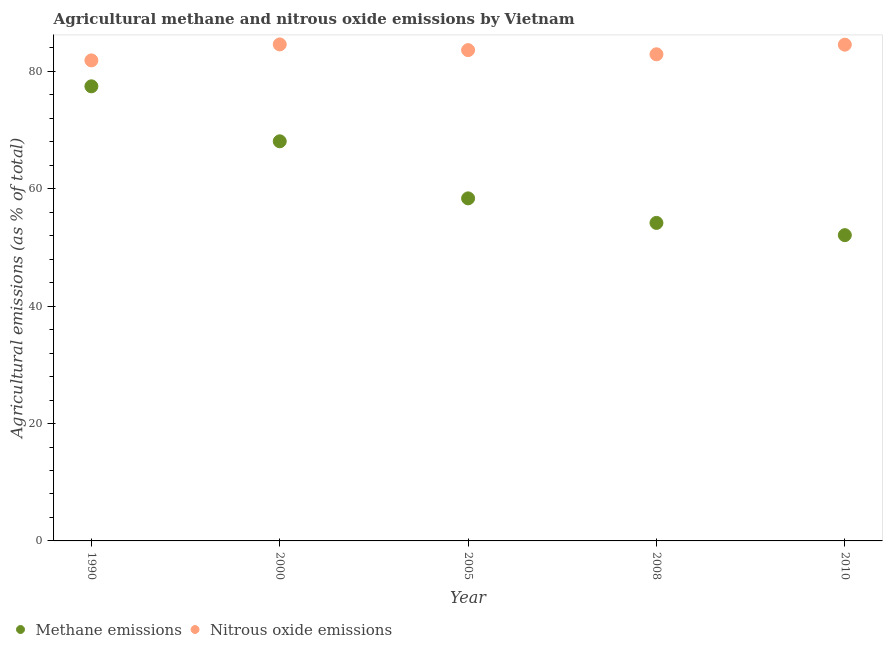How many different coloured dotlines are there?
Give a very brief answer. 2. What is the amount of methane emissions in 2000?
Your response must be concise. 68.1. Across all years, what is the maximum amount of methane emissions?
Offer a very short reply. 77.47. Across all years, what is the minimum amount of methane emissions?
Your answer should be very brief. 52.11. In which year was the amount of nitrous oxide emissions minimum?
Offer a terse response. 1990. What is the total amount of methane emissions in the graph?
Your answer should be very brief. 310.24. What is the difference between the amount of methane emissions in 2000 and that in 2005?
Your answer should be very brief. 9.72. What is the difference between the amount of methane emissions in 2010 and the amount of nitrous oxide emissions in 2008?
Ensure brevity in your answer.  -30.82. What is the average amount of methane emissions per year?
Your answer should be very brief. 62.05. In the year 1990, what is the difference between the amount of nitrous oxide emissions and amount of methane emissions?
Keep it short and to the point. 4.42. What is the ratio of the amount of methane emissions in 1990 to that in 2010?
Make the answer very short. 1.49. Is the amount of nitrous oxide emissions in 1990 less than that in 2000?
Make the answer very short. Yes. Is the difference between the amount of nitrous oxide emissions in 2000 and 2008 greater than the difference between the amount of methane emissions in 2000 and 2008?
Offer a terse response. No. What is the difference between the highest and the second highest amount of nitrous oxide emissions?
Provide a succinct answer. 0.04. What is the difference between the highest and the lowest amount of nitrous oxide emissions?
Offer a very short reply. 2.72. Does the amount of nitrous oxide emissions monotonically increase over the years?
Your response must be concise. No. Is the amount of methane emissions strictly greater than the amount of nitrous oxide emissions over the years?
Your answer should be compact. No. Is the amount of nitrous oxide emissions strictly less than the amount of methane emissions over the years?
Offer a terse response. No. How many dotlines are there?
Ensure brevity in your answer.  2. Are the values on the major ticks of Y-axis written in scientific E-notation?
Provide a succinct answer. No. How many legend labels are there?
Your answer should be very brief. 2. What is the title of the graph?
Ensure brevity in your answer.  Agricultural methane and nitrous oxide emissions by Vietnam. Does "Forest" appear as one of the legend labels in the graph?
Provide a succinct answer. No. What is the label or title of the X-axis?
Your response must be concise. Year. What is the label or title of the Y-axis?
Keep it short and to the point. Agricultural emissions (as % of total). What is the Agricultural emissions (as % of total) in Methane emissions in 1990?
Your answer should be very brief. 77.47. What is the Agricultural emissions (as % of total) of Nitrous oxide emissions in 1990?
Provide a short and direct response. 81.89. What is the Agricultural emissions (as % of total) in Methane emissions in 2000?
Offer a very short reply. 68.1. What is the Agricultural emissions (as % of total) in Nitrous oxide emissions in 2000?
Your response must be concise. 84.61. What is the Agricultural emissions (as % of total) in Methane emissions in 2005?
Provide a short and direct response. 58.37. What is the Agricultural emissions (as % of total) in Nitrous oxide emissions in 2005?
Offer a terse response. 83.64. What is the Agricultural emissions (as % of total) of Methane emissions in 2008?
Provide a short and direct response. 54.19. What is the Agricultural emissions (as % of total) in Nitrous oxide emissions in 2008?
Offer a terse response. 82.93. What is the Agricultural emissions (as % of total) in Methane emissions in 2010?
Give a very brief answer. 52.11. What is the Agricultural emissions (as % of total) in Nitrous oxide emissions in 2010?
Provide a short and direct response. 84.57. Across all years, what is the maximum Agricultural emissions (as % of total) of Methane emissions?
Offer a very short reply. 77.47. Across all years, what is the maximum Agricultural emissions (as % of total) in Nitrous oxide emissions?
Give a very brief answer. 84.61. Across all years, what is the minimum Agricultural emissions (as % of total) of Methane emissions?
Offer a very short reply. 52.11. Across all years, what is the minimum Agricultural emissions (as % of total) of Nitrous oxide emissions?
Ensure brevity in your answer.  81.89. What is the total Agricultural emissions (as % of total) in Methane emissions in the graph?
Offer a very short reply. 310.24. What is the total Agricultural emissions (as % of total) in Nitrous oxide emissions in the graph?
Offer a terse response. 417.63. What is the difference between the Agricultural emissions (as % of total) of Methane emissions in 1990 and that in 2000?
Provide a short and direct response. 9.37. What is the difference between the Agricultural emissions (as % of total) in Nitrous oxide emissions in 1990 and that in 2000?
Make the answer very short. -2.72. What is the difference between the Agricultural emissions (as % of total) in Methane emissions in 1990 and that in 2005?
Ensure brevity in your answer.  19.09. What is the difference between the Agricultural emissions (as % of total) in Nitrous oxide emissions in 1990 and that in 2005?
Your answer should be very brief. -1.75. What is the difference between the Agricultural emissions (as % of total) of Methane emissions in 1990 and that in 2008?
Keep it short and to the point. 23.28. What is the difference between the Agricultural emissions (as % of total) in Nitrous oxide emissions in 1990 and that in 2008?
Provide a short and direct response. -1.04. What is the difference between the Agricultural emissions (as % of total) of Methane emissions in 1990 and that in 2010?
Your response must be concise. 25.36. What is the difference between the Agricultural emissions (as % of total) in Nitrous oxide emissions in 1990 and that in 2010?
Your answer should be very brief. -2.68. What is the difference between the Agricultural emissions (as % of total) in Methane emissions in 2000 and that in 2005?
Provide a succinct answer. 9.72. What is the difference between the Agricultural emissions (as % of total) in Nitrous oxide emissions in 2000 and that in 2005?
Keep it short and to the point. 0.97. What is the difference between the Agricultural emissions (as % of total) in Methane emissions in 2000 and that in 2008?
Offer a terse response. 13.91. What is the difference between the Agricultural emissions (as % of total) in Nitrous oxide emissions in 2000 and that in 2008?
Keep it short and to the point. 1.68. What is the difference between the Agricultural emissions (as % of total) of Methane emissions in 2000 and that in 2010?
Provide a succinct answer. 15.99. What is the difference between the Agricultural emissions (as % of total) of Nitrous oxide emissions in 2000 and that in 2010?
Offer a very short reply. 0.04. What is the difference between the Agricultural emissions (as % of total) of Methane emissions in 2005 and that in 2008?
Give a very brief answer. 4.18. What is the difference between the Agricultural emissions (as % of total) of Nitrous oxide emissions in 2005 and that in 2008?
Ensure brevity in your answer.  0.71. What is the difference between the Agricultural emissions (as % of total) in Methane emissions in 2005 and that in 2010?
Make the answer very short. 6.27. What is the difference between the Agricultural emissions (as % of total) of Nitrous oxide emissions in 2005 and that in 2010?
Your answer should be very brief. -0.93. What is the difference between the Agricultural emissions (as % of total) of Methane emissions in 2008 and that in 2010?
Provide a short and direct response. 2.08. What is the difference between the Agricultural emissions (as % of total) of Nitrous oxide emissions in 2008 and that in 2010?
Make the answer very short. -1.64. What is the difference between the Agricultural emissions (as % of total) of Methane emissions in 1990 and the Agricultural emissions (as % of total) of Nitrous oxide emissions in 2000?
Provide a succinct answer. -7.14. What is the difference between the Agricultural emissions (as % of total) in Methane emissions in 1990 and the Agricultural emissions (as % of total) in Nitrous oxide emissions in 2005?
Offer a terse response. -6.17. What is the difference between the Agricultural emissions (as % of total) of Methane emissions in 1990 and the Agricultural emissions (as % of total) of Nitrous oxide emissions in 2008?
Provide a succinct answer. -5.46. What is the difference between the Agricultural emissions (as % of total) of Methane emissions in 1990 and the Agricultural emissions (as % of total) of Nitrous oxide emissions in 2010?
Provide a succinct answer. -7.1. What is the difference between the Agricultural emissions (as % of total) of Methane emissions in 2000 and the Agricultural emissions (as % of total) of Nitrous oxide emissions in 2005?
Offer a very short reply. -15.54. What is the difference between the Agricultural emissions (as % of total) of Methane emissions in 2000 and the Agricultural emissions (as % of total) of Nitrous oxide emissions in 2008?
Provide a succinct answer. -14.83. What is the difference between the Agricultural emissions (as % of total) in Methane emissions in 2000 and the Agricultural emissions (as % of total) in Nitrous oxide emissions in 2010?
Your answer should be very brief. -16.47. What is the difference between the Agricultural emissions (as % of total) of Methane emissions in 2005 and the Agricultural emissions (as % of total) of Nitrous oxide emissions in 2008?
Your answer should be very brief. -24.55. What is the difference between the Agricultural emissions (as % of total) of Methane emissions in 2005 and the Agricultural emissions (as % of total) of Nitrous oxide emissions in 2010?
Offer a terse response. -26.19. What is the difference between the Agricultural emissions (as % of total) in Methane emissions in 2008 and the Agricultural emissions (as % of total) in Nitrous oxide emissions in 2010?
Give a very brief answer. -30.38. What is the average Agricultural emissions (as % of total) of Methane emissions per year?
Give a very brief answer. 62.05. What is the average Agricultural emissions (as % of total) in Nitrous oxide emissions per year?
Your answer should be compact. 83.53. In the year 1990, what is the difference between the Agricultural emissions (as % of total) in Methane emissions and Agricultural emissions (as % of total) in Nitrous oxide emissions?
Make the answer very short. -4.42. In the year 2000, what is the difference between the Agricultural emissions (as % of total) in Methane emissions and Agricultural emissions (as % of total) in Nitrous oxide emissions?
Make the answer very short. -16.51. In the year 2005, what is the difference between the Agricultural emissions (as % of total) in Methane emissions and Agricultural emissions (as % of total) in Nitrous oxide emissions?
Provide a succinct answer. -25.26. In the year 2008, what is the difference between the Agricultural emissions (as % of total) of Methane emissions and Agricultural emissions (as % of total) of Nitrous oxide emissions?
Your answer should be very brief. -28.73. In the year 2010, what is the difference between the Agricultural emissions (as % of total) in Methane emissions and Agricultural emissions (as % of total) in Nitrous oxide emissions?
Your answer should be very brief. -32.46. What is the ratio of the Agricultural emissions (as % of total) in Methane emissions in 1990 to that in 2000?
Your answer should be compact. 1.14. What is the ratio of the Agricultural emissions (as % of total) of Nitrous oxide emissions in 1990 to that in 2000?
Offer a very short reply. 0.97. What is the ratio of the Agricultural emissions (as % of total) of Methane emissions in 1990 to that in 2005?
Ensure brevity in your answer.  1.33. What is the ratio of the Agricultural emissions (as % of total) of Nitrous oxide emissions in 1990 to that in 2005?
Provide a succinct answer. 0.98. What is the ratio of the Agricultural emissions (as % of total) of Methane emissions in 1990 to that in 2008?
Provide a short and direct response. 1.43. What is the ratio of the Agricultural emissions (as % of total) of Nitrous oxide emissions in 1990 to that in 2008?
Your answer should be compact. 0.99. What is the ratio of the Agricultural emissions (as % of total) in Methane emissions in 1990 to that in 2010?
Provide a short and direct response. 1.49. What is the ratio of the Agricultural emissions (as % of total) of Nitrous oxide emissions in 1990 to that in 2010?
Offer a very short reply. 0.97. What is the ratio of the Agricultural emissions (as % of total) of Methane emissions in 2000 to that in 2005?
Keep it short and to the point. 1.17. What is the ratio of the Agricultural emissions (as % of total) in Nitrous oxide emissions in 2000 to that in 2005?
Provide a short and direct response. 1.01. What is the ratio of the Agricultural emissions (as % of total) of Methane emissions in 2000 to that in 2008?
Your answer should be very brief. 1.26. What is the ratio of the Agricultural emissions (as % of total) of Nitrous oxide emissions in 2000 to that in 2008?
Make the answer very short. 1.02. What is the ratio of the Agricultural emissions (as % of total) of Methane emissions in 2000 to that in 2010?
Make the answer very short. 1.31. What is the ratio of the Agricultural emissions (as % of total) in Nitrous oxide emissions in 2000 to that in 2010?
Provide a short and direct response. 1. What is the ratio of the Agricultural emissions (as % of total) in Methane emissions in 2005 to that in 2008?
Your answer should be very brief. 1.08. What is the ratio of the Agricultural emissions (as % of total) of Nitrous oxide emissions in 2005 to that in 2008?
Offer a very short reply. 1.01. What is the ratio of the Agricultural emissions (as % of total) in Methane emissions in 2005 to that in 2010?
Provide a short and direct response. 1.12. What is the ratio of the Agricultural emissions (as % of total) in Methane emissions in 2008 to that in 2010?
Provide a short and direct response. 1.04. What is the ratio of the Agricultural emissions (as % of total) in Nitrous oxide emissions in 2008 to that in 2010?
Your answer should be very brief. 0.98. What is the difference between the highest and the second highest Agricultural emissions (as % of total) in Methane emissions?
Provide a succinct answer. 9.37. What is the difference between the highest and the second highest Agricultural emissions (as % of total) of Nitrous oxide emissions?
Offer a terse response. 0.04. What is the difference between the highest and the lowest Agricultural emissions (as % of total) in Methane emissions?
Provide a short and direct response. 25.36. What is the difference between the highest and the lowest Agricultural emissions (as % of total) in Nitrous oxide emissions?
Offer a terse response. 2.72. 